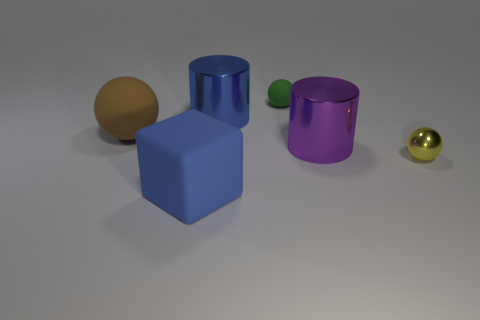The shiny cylinder that is the same color as the cube is what size?
Your answer should be very brief. Large. Do the big block and the small metallic sphere have the same color?
Offer a very short reply. No. There is a blue thing that is behind the yellow shiny sphere; what material is it?
Your answer should be compact. Metal. What number of small objects are red matte blocks or purple metal things?
Your response must be concise. 0. There is a thing that is the same color as the big matte block; what material is it?
Provide a short and direct response. Metal. Are there any objects that have the same material as the blue block?
Ensure brevity in your answer.  Yes. There is a matte ball that is left of the blue matte block; is its size the same as the blue matte object?
Give a very brief answer. Yes. Are there any objects to the right of the tiny sphere that is behind the shiny cylinder that is behind the purple cylinder?
Your answer should be compact. Yes. How many rubber things are either large red cubes or brown objects?
Your answer should be compact. 1. What number of other objects are there of the same shape as the tiny rubber thing?
Provide a short and direct response. 2. 